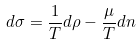Convert formula to latex. <formula><loc_0><loc_0><loc_500><loc_500>d \sigma = \frac { 1 } { T } d \rho - \frac { \mu } { T } d n</formula> 